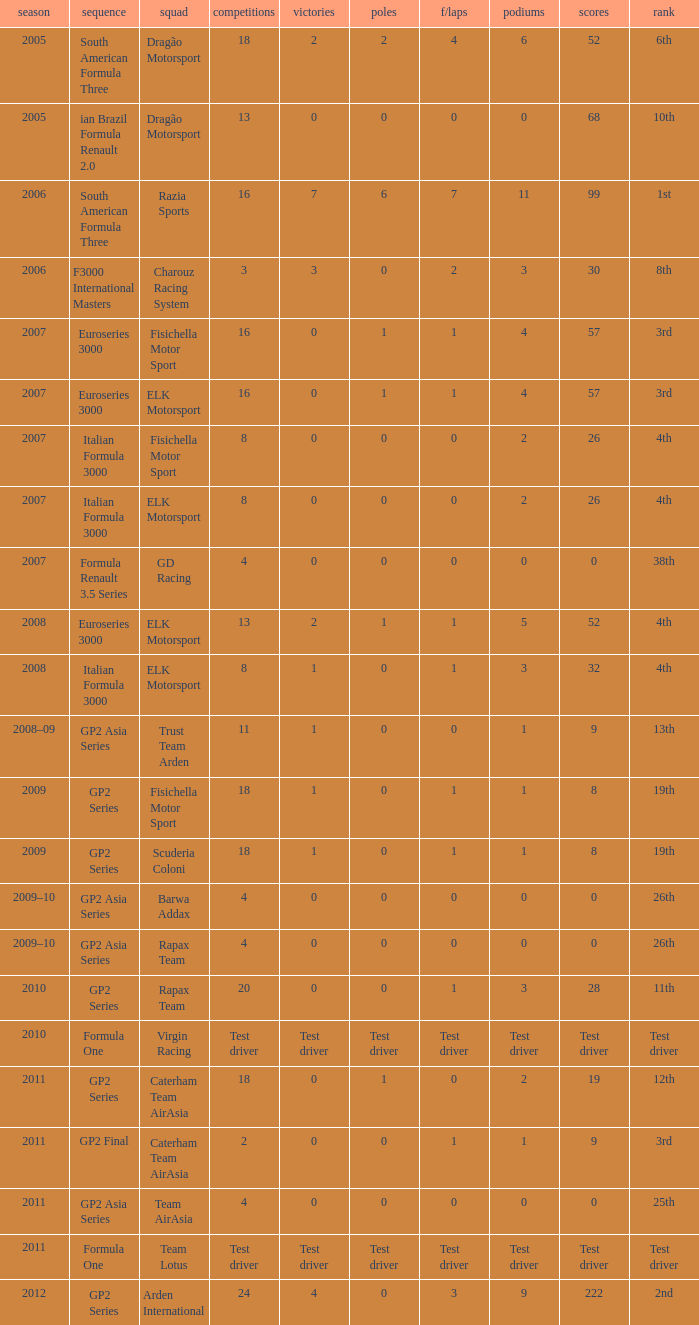What was the F/Laps when the Wins were 0 and the Position was 4th? 0, 0. 